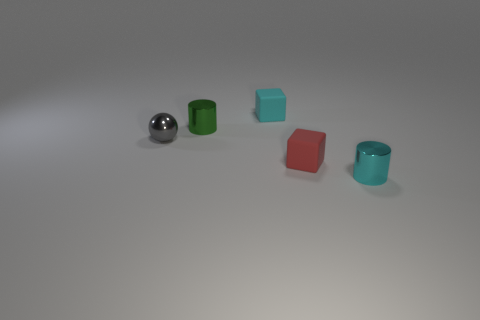Add 1 small metal spheres. How many objects exist? 6 Subtract all blocks. How many objects are left? 3 Subtract all green metallic things. Subtract all small gray shiny balls. How many objects are left? 3 Add 4 small cyan cubes. How many small cyan cubes are left? 5 Add 3 gray spheres. How many gray spheres exist? 4 Subtract 0 cyan spheres. How many objects are left? 5 